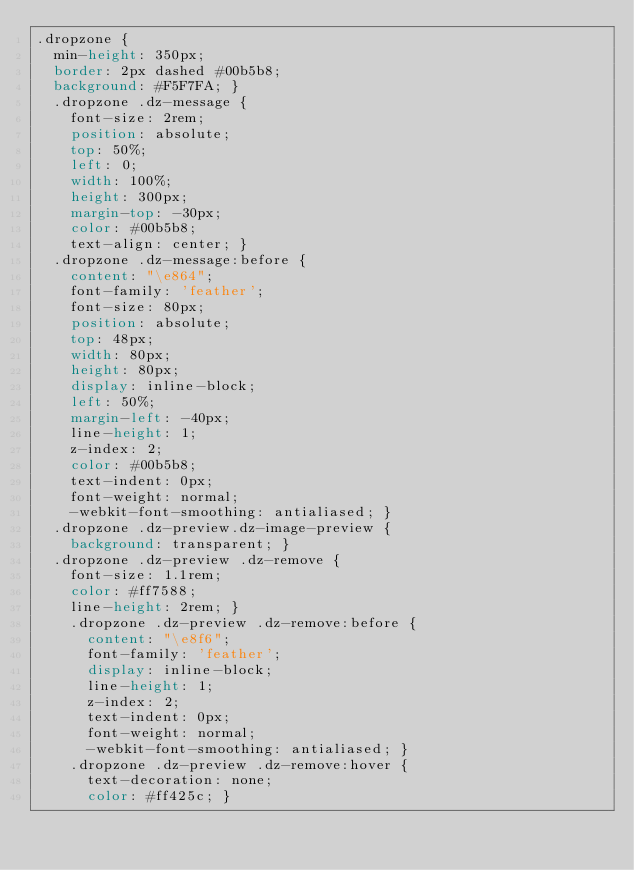Convert code to text. <code><loc_0><loc_0><loc_500><loc_500><_CSS_>.dropzone {
  min-height: 350px;
  border: 2px dashed #00b5b8;
  background: #F5F7FA; }
  .dropzone .dz-message {
    font-size: 2rem;
    position: absolute;
    top: 50%;
    left: 0;
    width: 100%;
    height: 300px;
    margin-top: -30px;
    color: #00b5b8;
    text-align: center; }
  .dropzone .dz-message:before {
    content: "\e864";
    font-family: 'feather';
    font-size: 80px;
    position: absolute;
    top: 48px;
    width: 80px;
    height: 80px;
    display: inline-block;
    left: 50%;
    margin-left: -40px;
    line-height: 1;
    z-index: 2;
    color: #00b5b8;
    text-indent: 0px;
    font-weight: normal;
    -webkit-font-smoothing: antialiased; }
  .dropzone .dz-preview.dz-image-preview {
    background: transparent; }
  .dropzone .dz-preview .dz-remove {
    font-size: 1.1rem;
    color: #ff7588;
    line-height: 2rem; }
    .dropzone .dz-preview .dz-remove:before {
      content: "\e8f6";
      font-family: 'feather';
      display: inline-block;
      line-height: 1;
      z-index: 2;
      text-indent: 0px;
      font-weight: normal;
      -webkit-font-smoothing: antialiased; }
    .dropzone .dz-preview .dz-remove:hover {
      text-decoration: none;
      color: #ff425c; }
</code> 